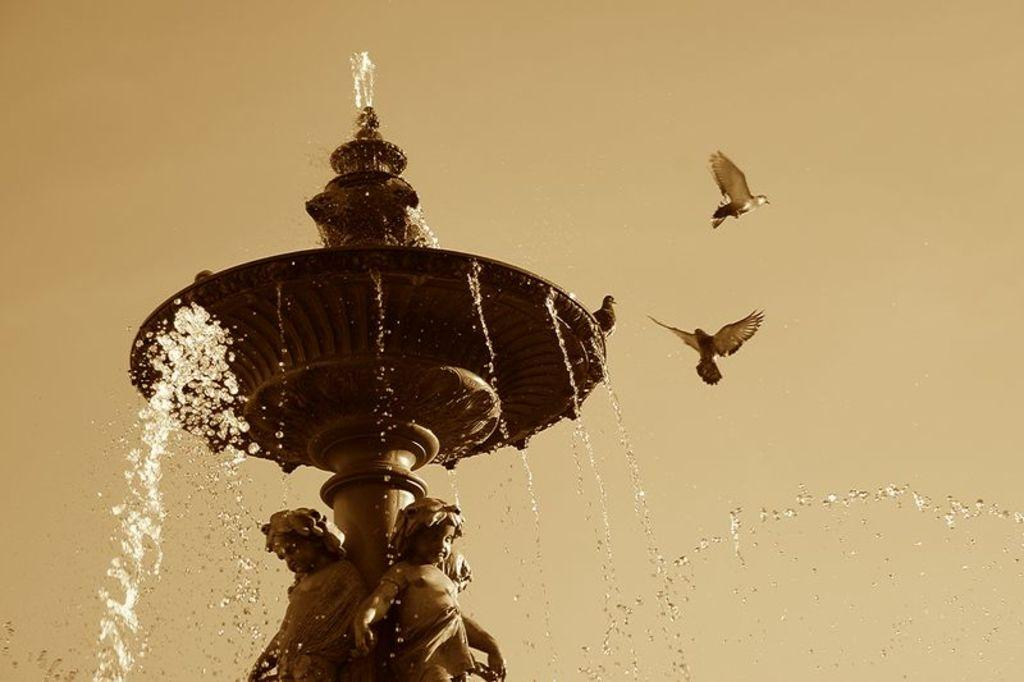What is happening with the birds in the image? There are two birds flying in the air, and one bird is sitting on a water fountain. Can you describe the actions of the birds in the image? The two birds are flying, while the third bird is perched on the water fountain. How many carpenters are visible in the image? There are no carpenters present in the image; it features birds. What color is the ladybug on the water fountain? There is no ladybug present in the image; it features birds. 